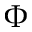Convert formula to latex. <formula><loc_0><loc_0><loc_500><loc_500>\Phi</formula> 